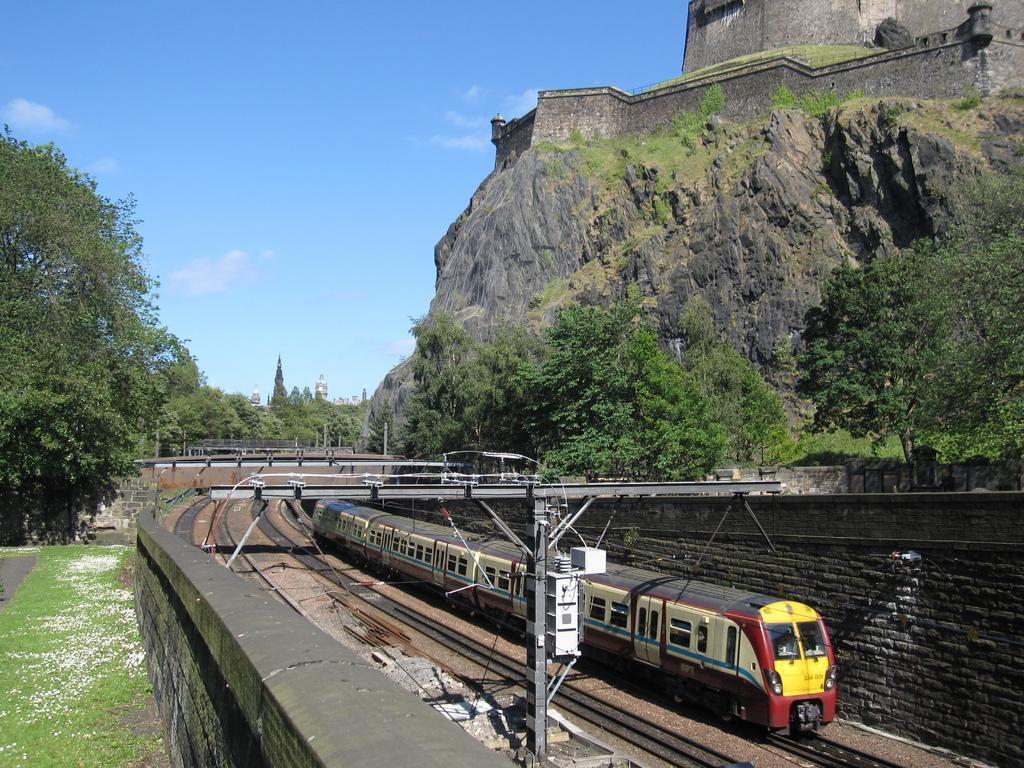How would you summarize this image in a sentence or two? In this image I can see a train on the railway track. On the left and right side, I can see the trees. I can see the rock. In the background, I can see the clouds in the sky. 